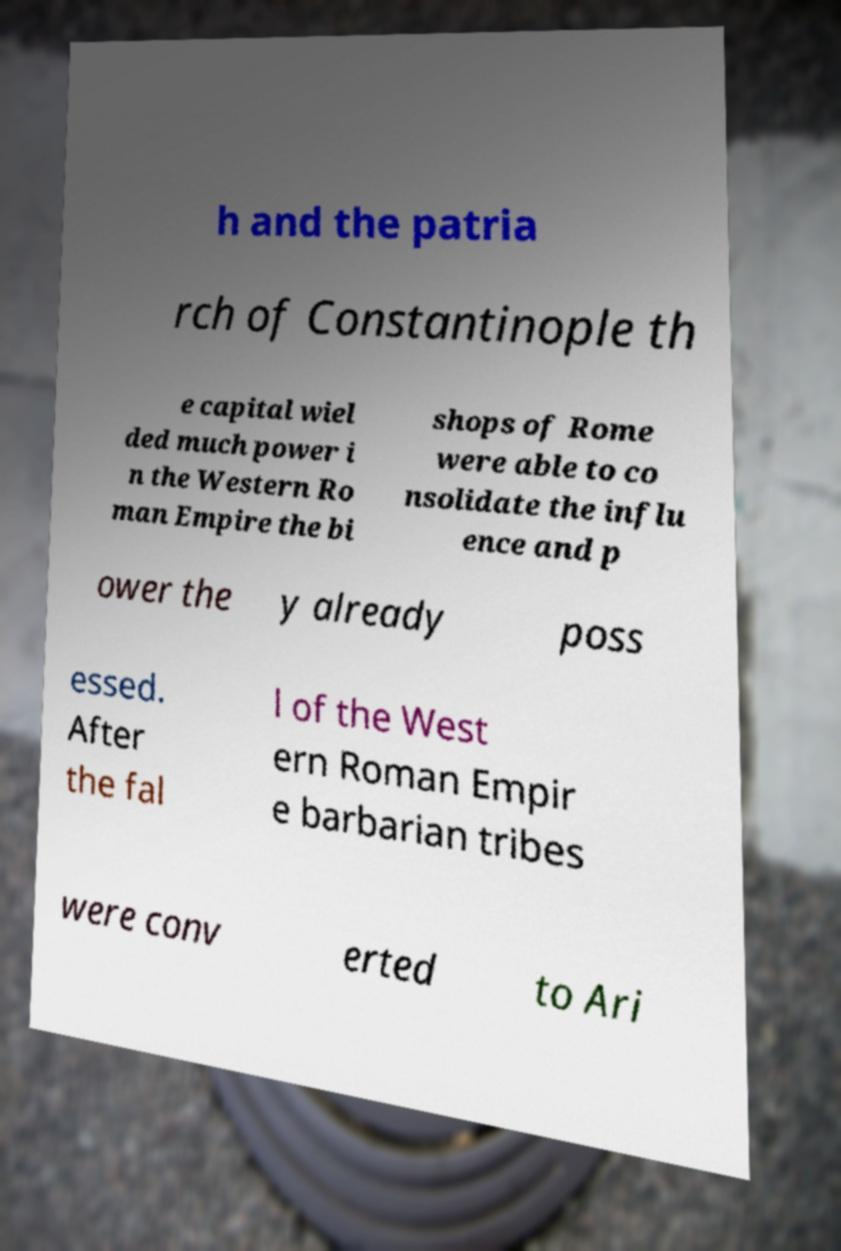There's text embedded in this image that I need extracted. Can you transcribe it verbatim? h and the patria rch of Constantinople th e capital wiel ded much power i n the Western Ro man Empire the bi shops of Rome were able to co nsolidate the influ ence and p ower the y already poss essed. After the fal l of the West ern Roman Empir e barbarian tribes were conv erted to Ari 